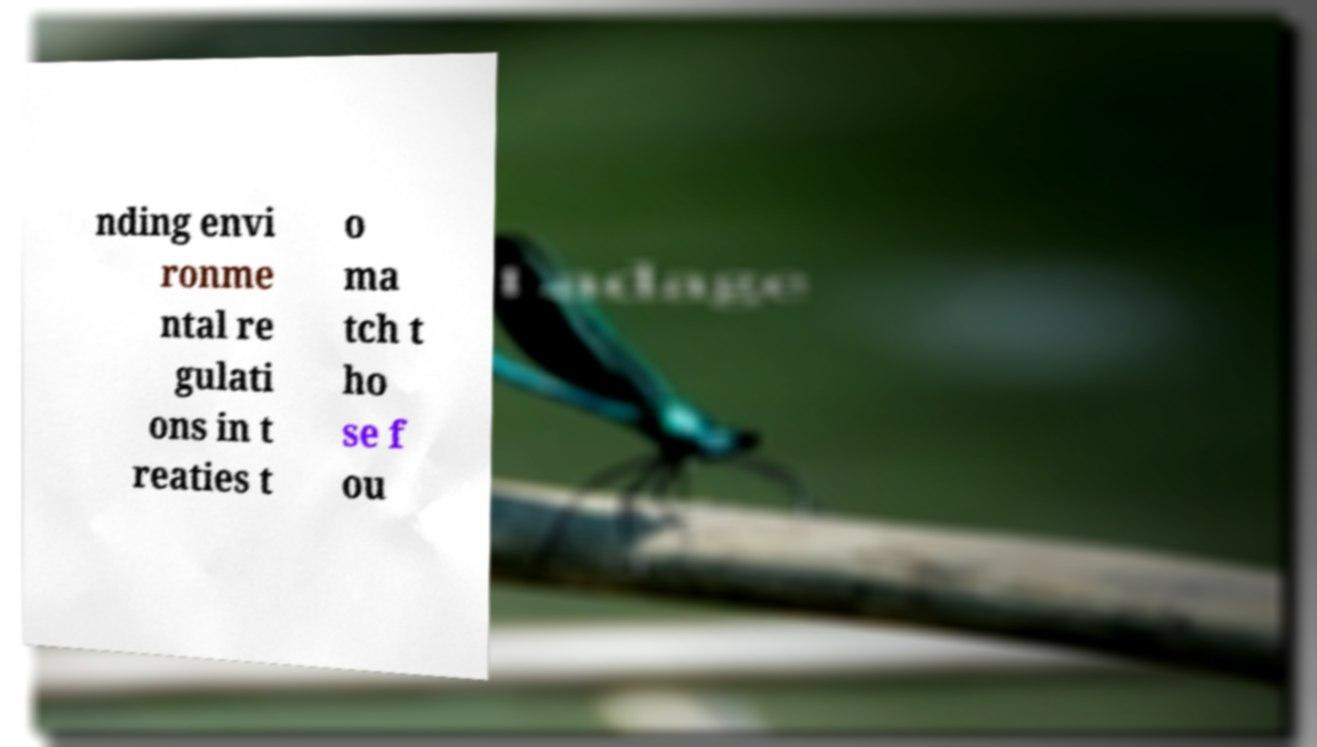There's text embedded in this image that I need extracted. Can you transcribe it verbatim? nding envi ronme ntal re gulati ons in t reaties t o ma tch t ho se f ou 